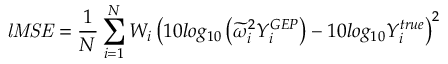<formula> <loc_0><loc_0><loc_500><loc_500>l M S E = \frac { 1 } { N } \sum _ { i = 1 } ^ { N } W _ { i } \left ( 1 0 \log _ { 1 0 } \left ( \widetilde { \omega } _ { i } ^ { 2 } Y _ { i } ^ { G E P } \right ) - 1 0 \log _ { 1 0 } Y _ { i } ^ { t r u e } \right ) ^ { 2 }</formula> 